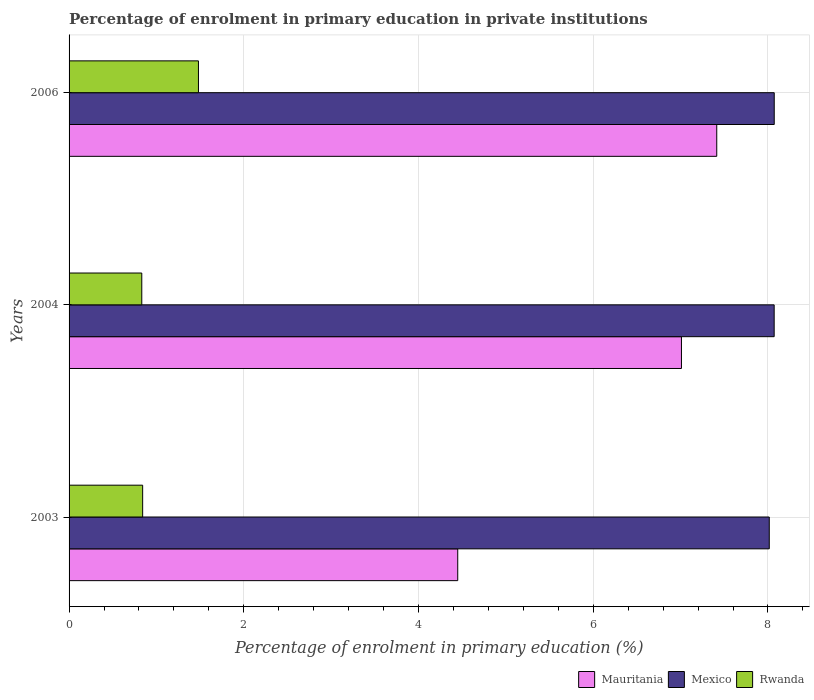How many different coloured bars are there?
Make the answer very short. 3. Are the number of bars per tick equal to the number of legend labels?
Your answer should be compact. Yes. Are the number of bars on each tick of the Y-axis equal?
Your response must be concise. Yes. How many bars are there on the 1st tick from the top?
Provide a short and direct response. 3. In how many cases, is the number of bars for a given year not equal to the number of legend labels?
Your answer should be very brief. 0. What is the percentage of enrolment in primary education in Mauritania in 2006?
Provide a short and direct response. 7.41. Across all years, what is the maximum percentage of enrolment in primary education in Rwanda?
Keep it short and to the point. 1.48. Across all years, what is the minimum percentage of enrolment in primary education in Rwanda?
Keep it short and to the point. 0.83. In which year was the percentage of enrolment in primary education in Rwanda minimum?
Give a very brief answer. 2004. What is the total percentage of enrolment in primary education in Rwanda in the graph?
Your answer should be compact. 3.16. What is the difference between the percentage of enrolment in primary education in Rwanda in 2004 and that in 2006?
Ensure brevity in your answer.  -0.65. What is the difference between the percentage of enrolment in primary education in Rwanda in 2006 and the percentage of enrolment in primary education in Mexico in 2003?
Give a very brief answer. -6.53. What is the average percentage of enrolment in primary education in Rwanda per year?
Your answer should be very brief. 1.05. In the year 2003, what is the difference between the percentage of enrolment in primary education in Mexico and percentage of enrolment in primary education in Rwanda?
Provide a succinct answer. 7.17. What is the ratio of the percentage of enrolment in primary education in Mexico in 2004 to that in 2006?
Your answer should be compact. 1. Is the difference between the percentage of enrolment in primary education in Mexico in 2003 and 2006 greater than the difference between the percentage of enrolment in primary education in Rwanda in 2003 and 2006?
Provide a short and direct response. Yes. What is the difference between the highest and the second highest percentage of enrolment in primary education in Mexico?
Provide a succinct answer. 0. What is the difference between the highest and the lowest percentage of enrolment in primary education in Rwanda?
Make the answer very short. 0.65. Is the sum of the percentage of enrolment in primary education in Rwanda in 2003 and 2006 greater than the maximum percentage of enrolment in primary education in Mexico across all years?
Ensure brevity in your answer.  No. What does the 2nd bar from the top in 2003 represents?
Give a very brief answer. Mexico. What does the 1st bar from the bottom in 2006 represents?
Your answer should be very brief. Mauritania. Are all the bars in the graph horizontal?
Ensure brevity in your answer.  Yes. What is the difference between two consecutive major ticks on the X-axis?
Your answer should be compact. 2. Are the values on the major ticks of X-axis written in scientific E-notation?
Offer a very short reply. No. Does the graph contain any zero values?
Keep it short and to the point. No. Does the graph contain grids?
Provide a short and direct response. Yes. How many legend labels are there?
Your response must be concise. 3. What is the title of the graph?
Offer a terse response. Percentage of enrolment in primary education in private institutions. Does "Samoa" appear as one of the legend labels in the graph?
Your answer should be very brief. No. What is the label or title of the X-axis?
Give a very brief answer. Percentage of enrolment in primary education (%). What is the Percentage of enrolment in primary education (%) of Mauritania in 2003?
Ensure brevity in your answer.  4.45. What is the Percentage of enrolment in primary education (%) in Mexico in 2003?
Provide a succinct answer. 8.02. What is the Percentage of enrolment in primary education (%) in Rwanda in 2003?
Keep it short and to the point. 0.84. What is the Percentage of enrolment in primary education (%) of Mauritania in 2004?
Provide a short and direct response. 7.01. What is the Percentage of enrolment in primary education (%) of Mexico in 2004?
Keep it short and to the point. 8.07. What is the Percentage of enrolment in primary education (%) in Rwanda in 2004?
Ensure brevity in your answer.  0.83. What is the Percentage of enrolment in primary education (%) of Mauritania in 2006?
Your response must be concise. 7.41. What is the Percentage of enrolment in primary education (%) in Mexico in 2006?
Provide a succinct answer. 8.07. What is the Percentage of enrolment in primary education (%) in Rwanda in 2006?
Provide a short and direct response. 1.48. Across all years, what is the maximum Percentage of enrolment in primary education (%) in Mauritania?
Your answer should be very brief. 7.41. Across all years, what is the maximum Percentage of enrolment in primary education (%) in Mexico?
Keep it short and to the point. 8.07. Across all years, what is the maximum Percentage of enrolment in primary education (%) in Rwanda?
Ensure brevity in your answer.  1.48. Across all years, what is the minimum Percentage of enrolment in primary education (%) in Mauritania?
Offer a terse response. 4.45. Across all years, what is the minimum Percentage of enrolment in primary education (%) in Mexico?
Your answer should be very brief. 8.02. Across all years, what is the minimum Percentage of enrolment in primary education (%) in Rwanda?
Offer a terse response. 0.83. What is the total Percentage of enrolment in primary education (%) in Mauritania in the graph?
Provide a short and direct response. 18.87. What is the total Percentage of enrolment in primary education (%) in Mexico in the graph?
Offer a very short reply. 24.16. What is the total Percentage of enrolment in primary education (%) in Rwanda in the graph?
Provide a short and direct response. 3.16. What is the difference between the Percentage of enrolment in primary education (%) of Mauritania in 2003 and that in 2004?
Your answer should be compact. -2.56. What is the difference between the Percentage of enrolment in primary education (%) of Mexico in 2003 and that in 2004?
Provide a succinct answer. -0.06. What is the difference between the Percentage of enrolment in primary education (%) of Rwanda in 2003 and that in 2004?
Provide a short and direct response. 0.01. What is the difference between the Percentage of enrolment in primary education (%) in Mauritania in 2003 and that in 2006?
Offer a terse response. -2.96. What is the difference between the Percentage of enrolment in primary education (%) of Mexico in 2003 and that in 2006?
Your response must be concise. -0.06. What is the difference between the Percentage of enrolment in primary education (%) in Rwanda in 2003 and that in 2006?
Offer a very short reply. -0.64. What is the difference between the Percentage of enrolment in primary education (%) in Mauritania in 2004 and that in 2006?
Keep it short and to the point. -0.4. What is the difference between the Percentage of enrolment in primary education (%) of Mexico in 2004 and that in 2006?
Provide a short and direct response. -0. What is the difference between the Percentage of enrolment in primary education (%) of Rwanda in 2004 and that in 2006?
Keep it short and to the point. -0.65. What is the difference between the Percentage of enrolment in primary education (%) of Mauritania in 2003 and the Percentage of enrolment in primary education (%) of Mexico in 2004?
Your answer should be compact. -3.62. What is the difference between the Percentage of enrolment in primary education (%) of Mauritania in 2003 and the Percentage of enrolment in primary education (%) of Rwanda in 2004?
Make the answer very short. 3.62. What is the difference between the Percentage of enrolment in primary education (%) in Mexico in 2003 and the Percentage of enrolment in primary education (%) in Rwanda in 2004?
Make the answer very short. 7.18. What is the difference between the Percentage of enrolment in primary education (%) of Mauritania in 2003 and the Percentage of enrolment in primary education (%) of Mexico in 2006?
Give a very brief answer. -3.62. What is the difference between the Percentage of enrolment in primary education (%) of Mauritania in 2003 and the Percentage of enrolment in primary education (%) of Rwanda in 2006?
Ensure brevity in your answer.  2.97. What is the difference between the Percentage of enrolment in primary education (%) of Mexico in 2003 and the Percentage of enrolment in primary education (%) of Rwanda in 2006?
Offer a very short reply. 6.53. What is the difference between the Percentage of enrolment in primary education (%) of Mauritania in 2004 and the Percentage of enrolment in primary education (%) of Mexico in 2006?
Offer a very short reply. -1.06. What is the difference between the Percentage of enrolment in primary education (%) of Mauritania in 2004 and the Percentage of enrolment in primary education (%) of Rwanda in 2006?
Ensure brevity in your answer.  5.53. What is the difference between the Percentage of enrolment in primary education (%) of Mexico in 2004 and the Percentage of enrolment in primary education (%) of Rwanda in 2006?
Offer a terse response. 6.59. What is the average Percentage of enrolment in primary education (%) of Mauritania per year?
Offer a terse response. 6.29. What is the average Percentage of enrolment in primary education (%) of Mexico per year?
Keep it short and to the point. 8.05. What is the average Percentage of enrolment in primary education (%) of Rwanda per year?
Your response must be concise. 1.05. In the year 2003, what is the difference between the Percentage of enrolment in primary education (%) in Mauritania and Percentage of enrolment in primary education (%) in Mexico?
Ensure brevity in your answer.  -3.57. In the year 2003, what is the difference between the Percentage of enrolment in primary education (%) of Mauritania and Percentage of enrolment in primary education (%) of Rwanda?
Your answer should be very brief. 3.61. In the year 2003, what is the difference between the Percentage of enrolment in primary education (%) of Mexico and Percentage of enrolment in primary education (%) of Rwanda?
Offer a very short reply. 7.17. In the year 2004, what is the difference between the Percentage of enrolment in primary education (%) in Mauritania and Percentage of enrolment in primary education (%) in Mexico?
Provide a short and direct response. -1.06. In the year 2004, what is the difference between the Percentage of enrolment in primary education (%) of Mauritania and Percentage of enrolment in primary education (%) of Rwanda?
Offer a very short reply. 6.18. In the year 2004, what is the difference between the Percentage of enrolment in primary education (%) in Mexico and Percentage of enrolment in primary education (%) in Rwanda?
Make the answer very short. 7.24. In the year 2006, what is the difference between the Percentage of enrolment in primary education (%) in Mauritania and Percentage of enrolment in primary education (%) in Mexico?
Ensure brevity in your answer.  -0.66. In the year 2006, what is the difference between the Percentage of enrolment in primary education (%) in Mauritania and Percentage of enrolment in primary education (%) in Rwanda?
Your response must be concise. 5.93. In the year 2006, what is the difference between the Percentage of enrolment in primary education (%) of Mexico and Percentage of enrolment in primary education (%) of Rwanda?
Your response must be concise. 6.59. What is the ratio of the Percentage of enrolment in primary education (%) in Mauritania in 2003 to that in 2004?
Offer a very short reply. 0.63. What is the ratio of the Percentage of enrolment in primary education (%) in Mexico in 2003 to that in 2004?
Make the answer very short. 0.99. What is the ratio of the Percentage of enrolment in primary education (%) of Rwanda in 2003 to that in 2004?
Provide a short and direct response. 1.01. What is the ratio of the Percentage of enrolment in primary education (%) in Mauritania in 2003 to that in 2006?
Your answer should be very brief. 0.6. What is the ratio of the Percentage of enrolment in primary education (%) in Rwanda in 2003 to that in 2006?
Make the answer very short. 0.57. What is the ratio of the Percentage of enrolment in primary education (%) in Mauritania in 2004 to that in 2006?
Give a very brief answer. 0.95. What is the ratio of the Percentage of enrolment in primary education (%) in Rwanda in 2004 to that in 2006?
Make the answer very short. 0.56. What is the difference between the highest and the second highest Percentage of enrolment in primary education (%) in Mauritania?
Your answer should be very brief. 0.4. What is the difference between the highest and the second highest Percentage of enrolment in primary education (%) in Mexico?
Give a very brief answer. 0. What is the difference between the highest and the second highest Percentage of enrolment in primary education (%) in Rwanda?
Give a very brief answer. 0.64. What is the difference between the highest and the lowest Percentage of enrolment in primary education (%) in Mauritania?
Provide a short and direct response. 2.96. What is the difference between the highest and the lowest Percentage of enrolment in primary education (%) of Mexico?
Make the answer very short. 0.06. What is the difference between the highest and the lowest Percentage of enrolment in primary education (%) of Rwanda?
Your answer should be compact. 0.65. 